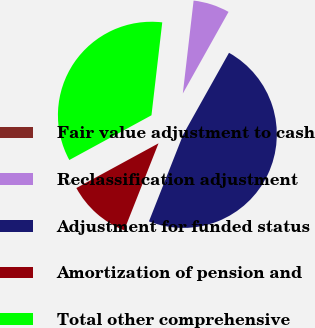<chart> <loc_0><loc_0><loc_500><loc_500><pie_chart><fcel>Fair value adjustment to cash<fcel>Reclassification adjustment<fcel>Adjustment for funded status<fcel>Amortization of pension and<fcel>Total other comprehensive<nl><fcel>0.0%<fcel>6.29%<fcel>47.85%<fcel>11.08%<fcel>34.77%<nl></chart> 